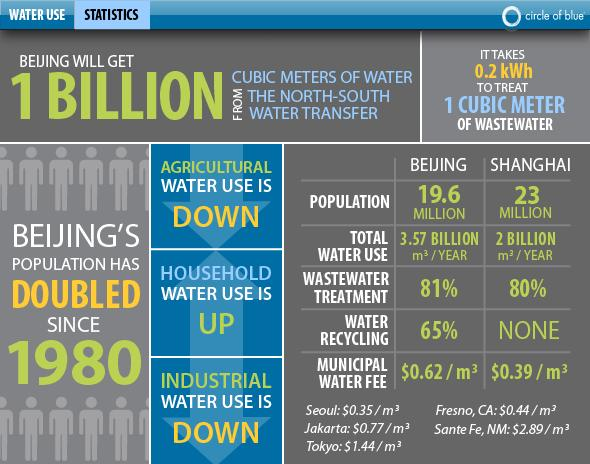Point out several critical features in this image. The percentage of wastewater treatment in Beijing and Shanghai, taken together, is 161%. According to a recent study, the percentage of water recycling in Beijing and Shanghai, taken together, is 65%. This is significant, as it demonstrates the cities' efforts to conserve water resources and reduce their reliance on traditional sources of water. 